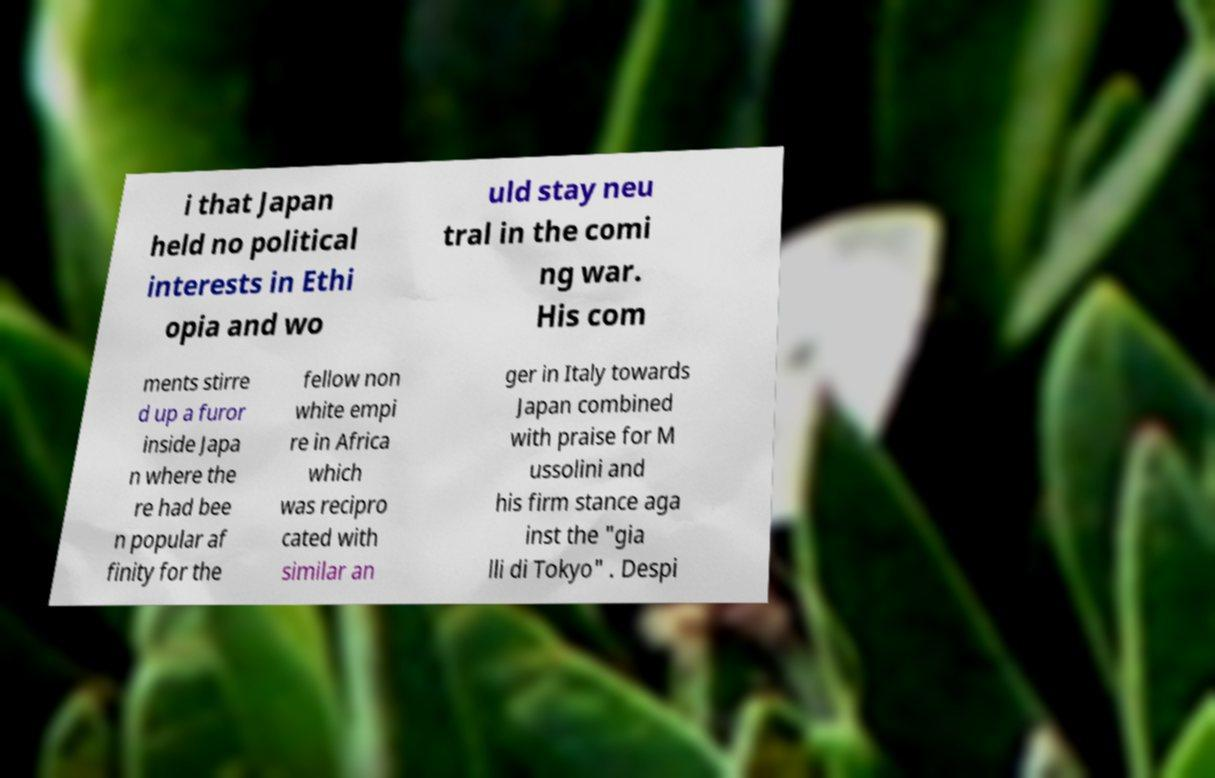I need the written content from this picture converted into text. Can you do that? i that Japan held no political interests in Ethi opia and wo uld stay neu tral in the comi ng war. His com ments stirre d up a furor inside Japa n where the re had bee n popular af finity for the fellow non white empi re in Africa which was recipro cated with similar an ger in Italy towards Japan combined with praise for M ussolini and his firm stance aga inst the "gia lli di Tokyo" . Despi 